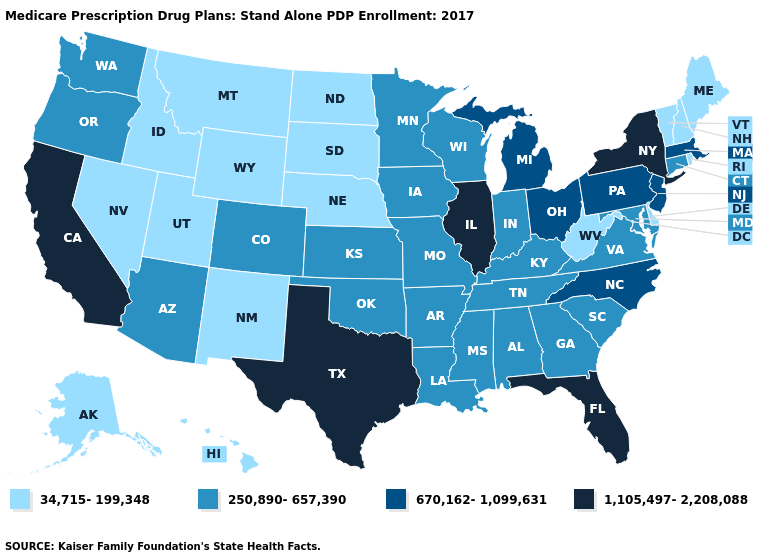What is the value of Kentucky?
Concise answer only. 250,890-657,390. What is the highest value in the USA?
Quick response, please. 1,105,497-2,208,088. Name the states that have a value in the range 34,715-199,348?
Quick response, please. Alaska, Delaware, Hawaii, Idaho, Maine, Montana, North Dakota, Nebraska, New Hampshire, New Mexico, Nevada, Rhode Island, South Dakota, Utah, Vermont, West Virginia, Wyoming. What is the highest value in states that border New Mexico?
Quick response, please. 1,105,497-2,208,088. Does the map have missing data?
Quick response, please. No. Does Minnesota have a lower value than North Carolina?
Quick response, please. Yes. Which states hav the highest value in the West?
Write a very short answer. California. Name the states that have a value in the range 250,890-657,390?
Concise answer only. Alabama, Arkansas, Arizona, Colorado, Connecticut, Georgia, Iowa, Indiana, Kansas, Kentucky, Louisiana, Maryland, Minnesota, Missouri, Mississippi, Oklahoma, Oregon, South Carolina, Tennessee, Virginia, Washington, Wisconsin. Does Pennsylvania have the highest value in the USA?
Keep it brief. No. Name the states that have a value in the range 250,890-657,390?
Be succinct. Alabama, Arkansas, Arizona, Colorado, Connecticut, Georgia, Iowa, Indiana, Kansas, Kentucky, Louisiana, Maryland, Minnesota, Missouri, Mississippi, Oklahoma, Oregon, South Carolina, Tennessee, Virginia, Washington, Wisconsin. Does Wyoming have the lowest value in the USA?
Concise answer only. Yes. Does Pennsylvania have a lower value than Nebraska?
Concise answer only. No. What is the value of Colorado?
Concise answer only. 250,890-657,390. What is the lowest value in states that border Nebraska?
Quick response, please. 34,715-199,348. Does the map have missing data?
Be succinct. No. 